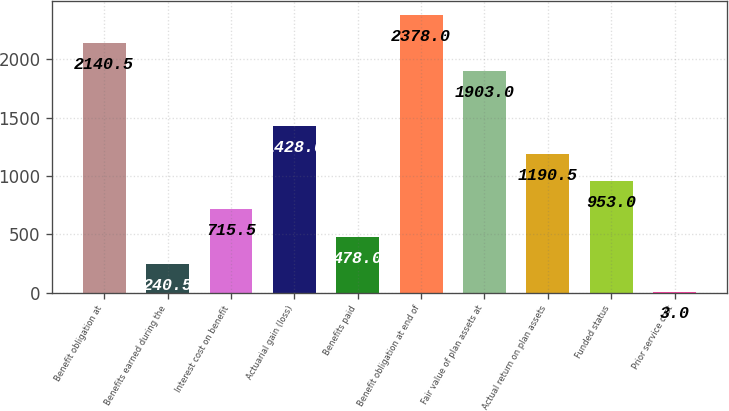Convert chart to OTSL. <chart><loc_0><loc_0><loc_500><loc_500><bar_chart><fcel>Benefit obligation at<fcel>Benefits earned during the<fcel>Interest cost on benefit<fcel>Actuarial gain (loss)<fcel>Benefits paid<fcel>Benefit obligation at end of<fcel>Fair value of plan assets at<fcel>Actual return on plan assets<fcel>Funded status<fcel>Prior service cost<nl><fcel>2140.5<fcel>240.5<fcel>715.5<fcel>1428<fcel>478<fcel>2378<fcel>1903<fcel>1190.5<fcel>953<fcel>3<nl></chart> 